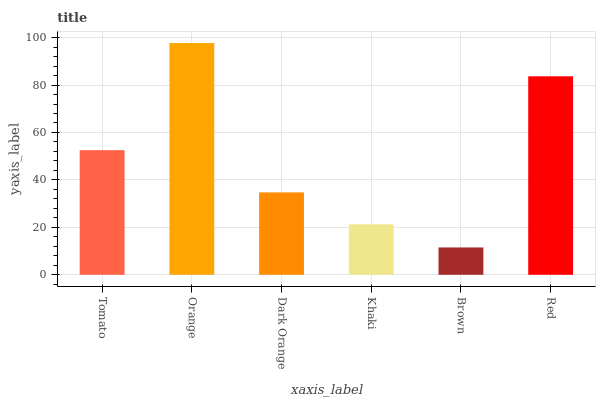Is Brown the minimum?
Answer yes or no. Yes. Is Orange the maximum?
Answer yes or no. Yes. Is Dark Orange the minimum?
Answer yes or no. No. Is Dark Orange the maximum?
Answer yes or no. No. Is Orange greater than Dark Orange?
Answer yes or no. Yes. Is Dark Orange less than Orange?
Answer yes or no. Yes. Is Dark Orange greater than Orange?
Answer yes or no. No. Is Orange less than Dark Orange?
Answer yes or no. No. Is Tomato the high median?
Answer yes or no. Yes. Is Dark Orange the low median?
Answer yes or no. Yes. Is Red the high median?
Answer yes or no. No. Is Red the low median?
Answer yes or no. No. 